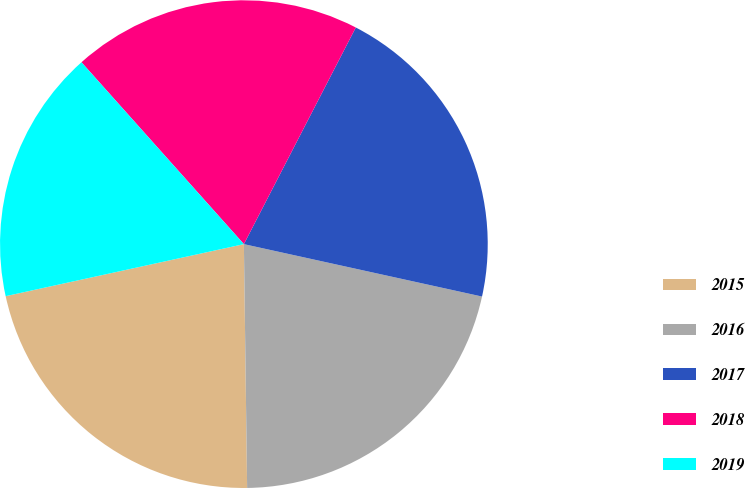<chart> <loc_0><loc_0><loc_500><loc_500><pie_chart><fcel>2015<fcel>2016<fcel>2017<fcel>2018<fcel>2019<nl><fcel>21.79%<fcel>21.34%<fcel>20.86%<fcel>19.19%<fcel>16.82%<nl></chart> 